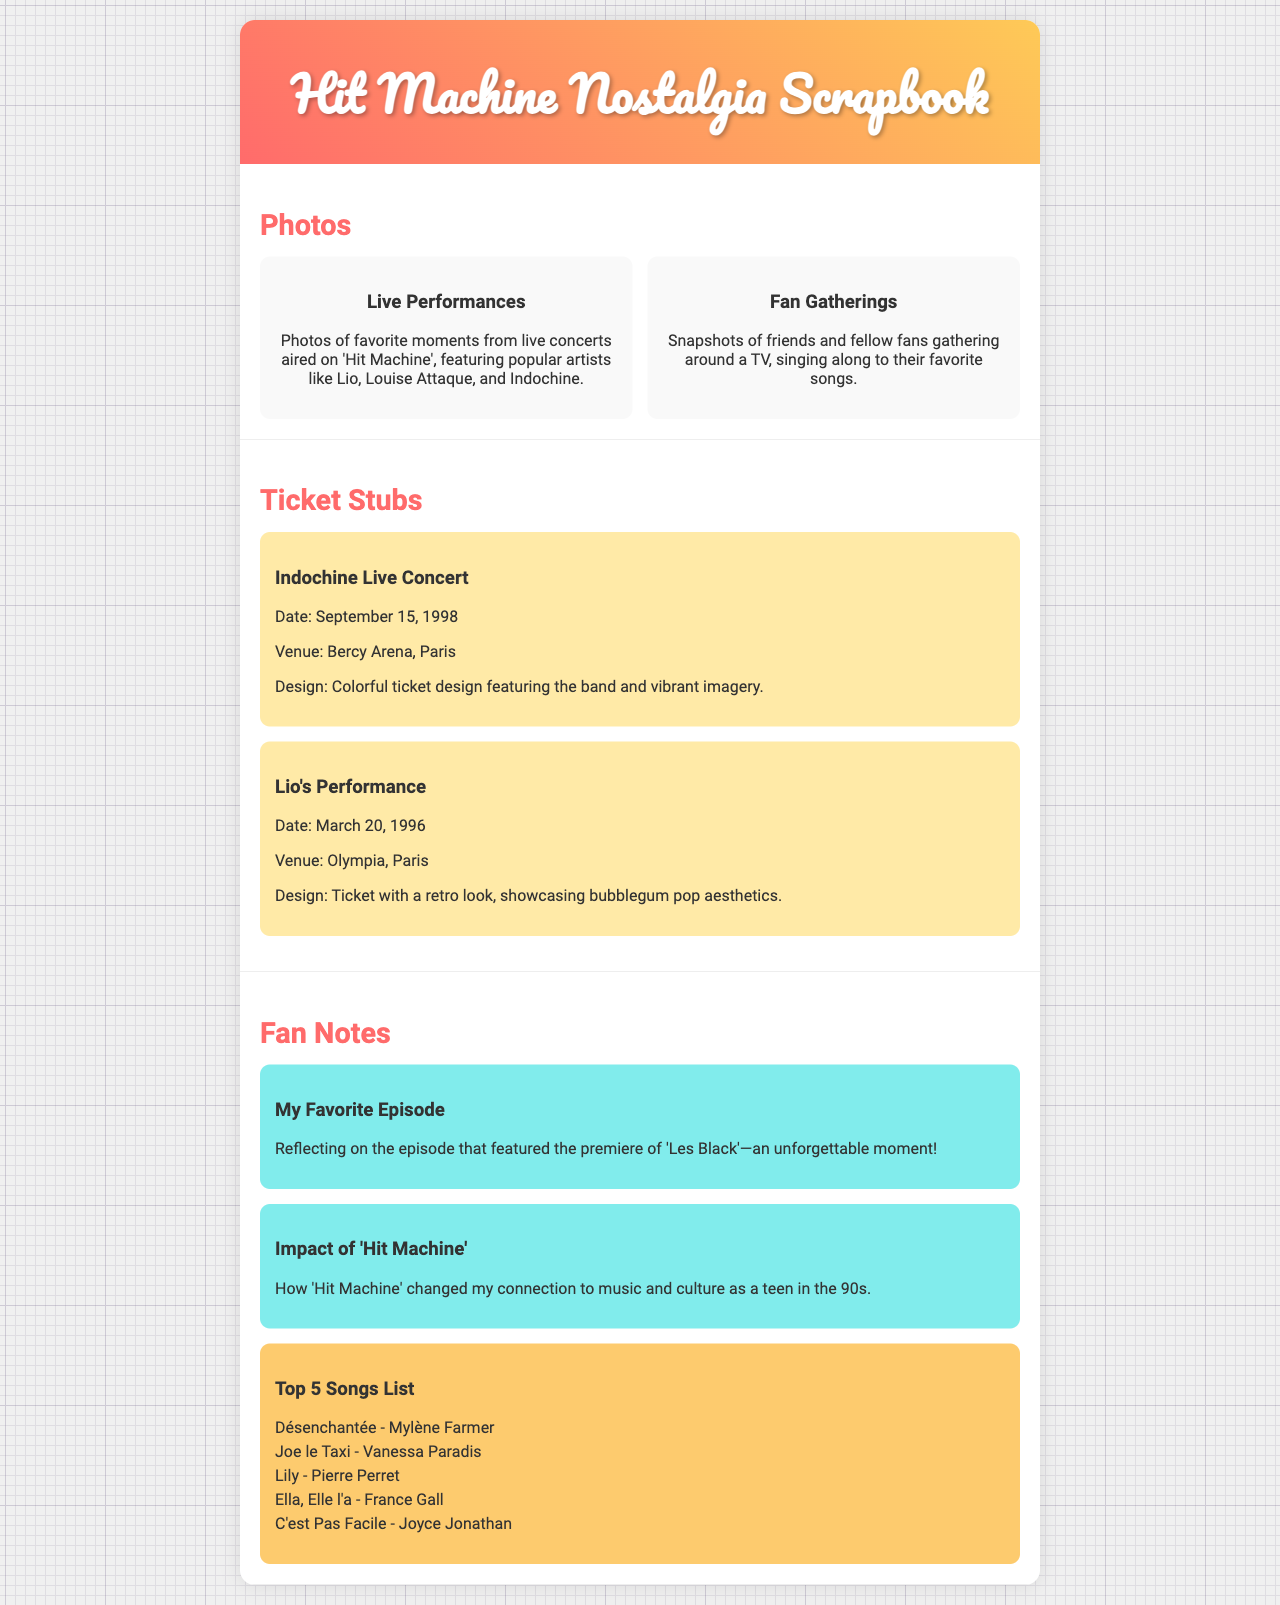What is the title of the scrapbook? The title of the scrapbook is prominently displayed in the header of the document.
Answer: Hit Machine Nostalgia Scrapbook Who performed on March 20, 1996? This information is found in the ticket stubs section, detailing performances and dates.
Answer: Lio What is the venue for Indochine's concert? The venue information is provided in the ticket stub details section for live performances.
Answer: Bercy Arena, Paris What is featured in the first photo item? The description of the first photo item indicates the type of content related to performances.
Answer: Live Performances How many songs are listed in the top 5 songs list? The top 5 songs list counts the total number of song titles displayed.
Answer: 5 Which song features Mylène Farmer? The song by Mylène Farmer can be identified from the song list section.
Answer: Désenchantée What colors are used in the scrapbook header? The background gradient colors specified in the header can be drawn from visual descriptions.
Answer: Pink and yellow What was the impact of 'Hit Machine' discussed in fan notes? The fan note section includes a reflection on the cultural significance of the show.
Answer: Culture 